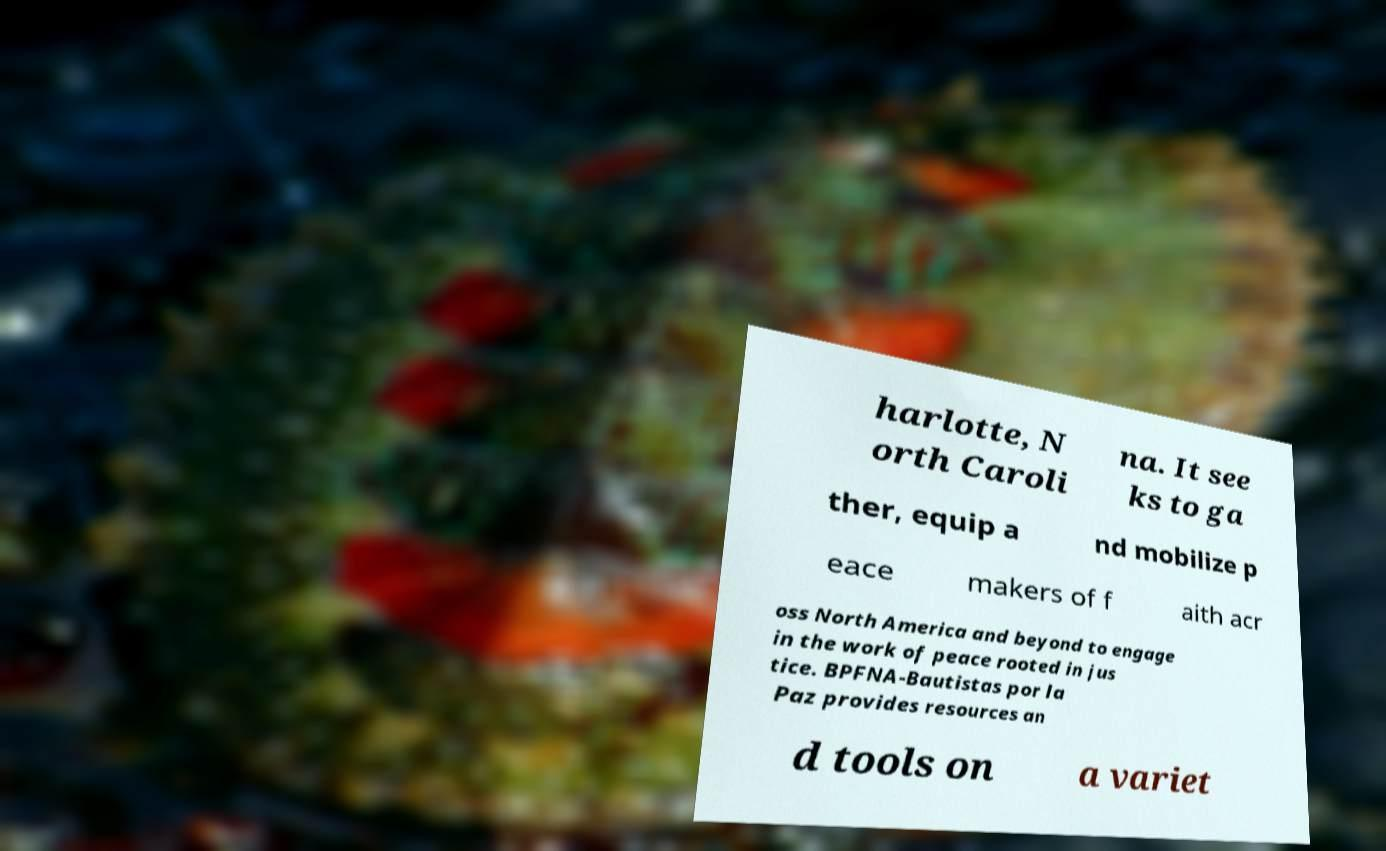Can you read and provide the text displayed in the image?This photo seems to have some interesting text. Can you extract and type it out for me? harlotte, N orth Caroli na. It see ks to ga ther, equip a nd mobilize p eace makers of f aith acr oss North America and beyond to engage in the work of peace rooted in jus tice. BPFNA-Bautistas por la Paz provides resources an d tools on a variet 